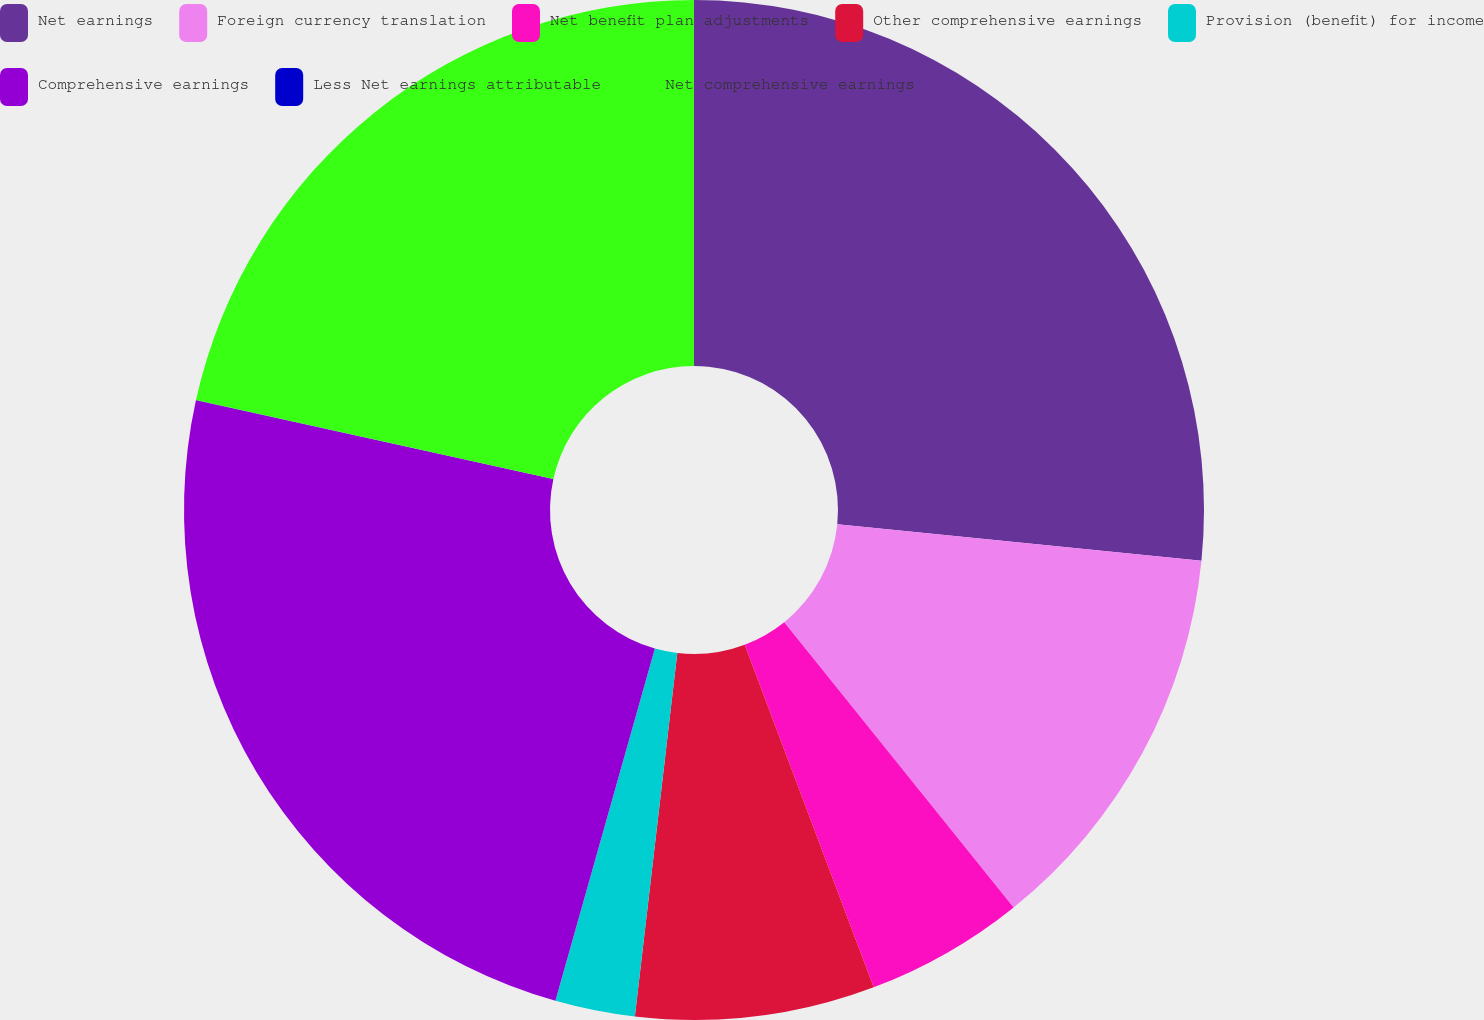Convert chart to OTSL. <chart><loc_0><loc_0><loc_500><loc_500><pie_chart><fcel>Net earnings<fcel>Foreign currency translation<fcel>Net benefit plan adjustments<fcel>Other comprehensive earnings<fcel>Provision (benefit) for income<fcel>Comprehensive earnings<fcel>Less Net earnings attributable<fcel>Net comprehensive earnings<nl><fcel>26.59%<fcel>12.63%<fcel>5.05%<fcel>7.58%<fcel>2.53%<fcel>24.07%<fcel>0.01%<fcel>21.54%<nl></chart> 